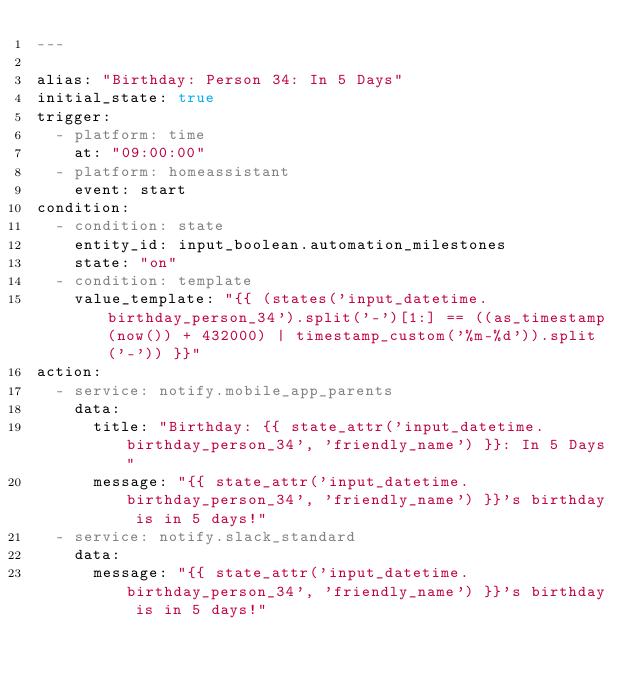Convert code to text. <code><loc_0><loc_0><loc_500><loc_500><_YAML_>---

alias: "Birthday: Person 34: In 5 Days"
initial_state: true
trigger:
  - platform: time
    at: "09:00:00"
  - platform: homeassistant
    event: start
condition:
  - condition: state
    entity_id: input_boolean.automation_milestones
    state: "on"
  - condition: template
    value_template: "{{ (states('input_datetime.birthday_person_34').split('-')[1:] == ((as_timestamp(now()) + 432000) | timestamp_custom('%m-%d')).split('-')) }}"
action:
  - service: notify.mobile_app_parents
    data:
      title: "Birthday: {{ state_attr('input_datetime.birthday_person_34', 'friendly_name') }}: In 5 Days"
      message: "{{ state_attr('input_datetime.birthday_person_34', 'friendly_name') }}'s birthday is in 5 days!"
  - service: notify.slack_standard
    data:
      message: "{{ state_attr('input_datetime.birthday_person_34', 'friendly_name') }}'s birthday is in 5 days!"
</code> 